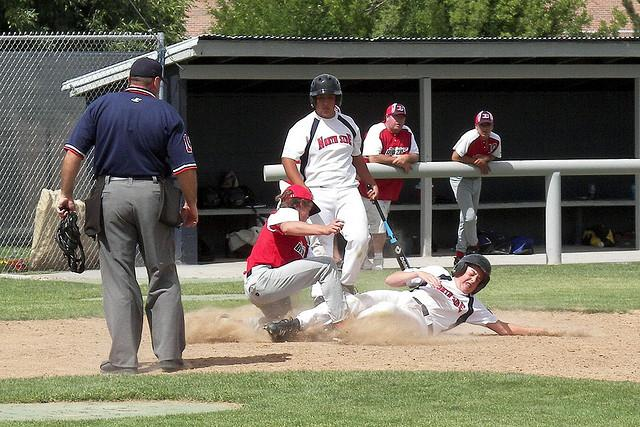Who famously helped win a 1992 playoff game doing what the boy in the black helmet is doing?

Choices:
A) jacob degrom
B) manny acta
C) pete schourek
D) sid bream sid bream 